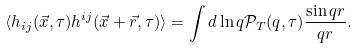Convert formula to latex. <formula><loc_0><loc_0><loc_500><loc_500>\langle h _ { i j } ( \vec { x } , \tau ) h ^ { i j } ( \vec { x } + \vec { r } , \tau ) \rangle = \int d \ln { q } { \mathcal { P } } _ { T } ( q , \tau ) \frac { \sin { q r } } { q r } .</formula> 